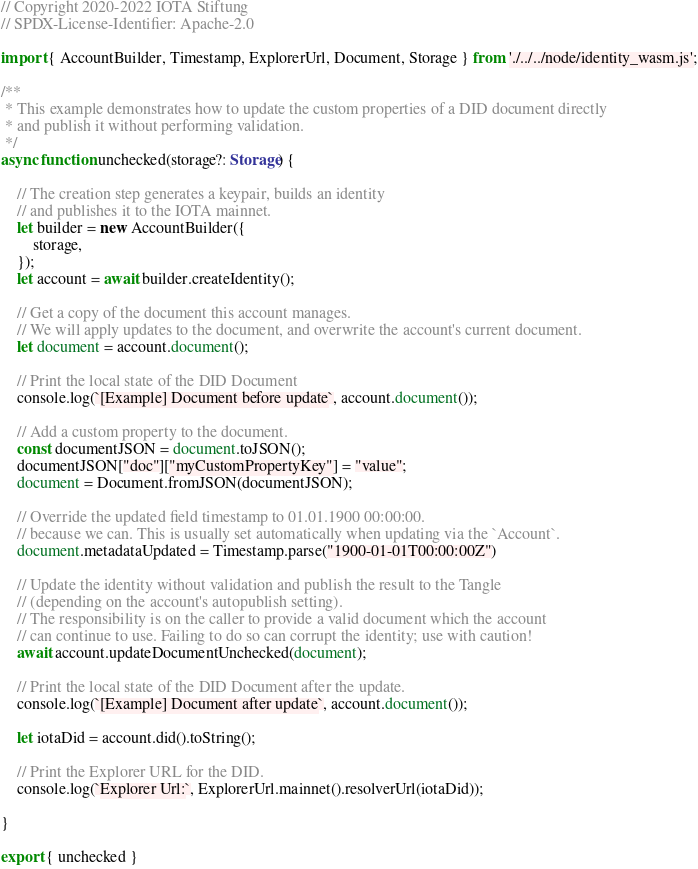Convert code to text. <code><loc_0><loc_0><loc_500><loc_500><_TypeScript_>// Copyright 2020-2022 IOTA Stiftung
// SPDX-License-Identifier: Apache-2.0

import { AccountBuilder, Timestamp, ExplorerUrl, Document, Storage } from './../../node/identity_wasm.js';

/**
 * This example demonstrates how to update the custom properties of a DID document directly 
 * and publish it without performing validation.
 */
async function unchecked(storage?: Storage) {

    // The creation step generates a keypair, builds an identity
    // and publishes it to the IOTA mainnet.
    let builder = new AccountBuilder({
        storage,
    });
    let account = await builder.createIdentity();

    // Get a copy of the document this account manages.
    // We will apply updates to the document, and overwrite the account's current document.
    let document = account.document();

    // Print the local state of the DID Document
    console.log(`[Example] Document before update`, account.document());

    // Add a custom property to the document.
    const documentJSON = document.toJSON();
    documentJSON["doc"]["myCustomPropertyKey"] = "value";
    document = Document.fromJSON(documentJSON);

    // Override the updated field timestamp to 01.01.1900 00:00:00.
    // because we can. This is usually set automatically when updating via the `Account`.
    document.metadataUpdated = Timestamp.parse("1900-01-01T00:00:00Z")

    // Update the identity without validation and publish the result to the Tangle
    // (depending on the account's autopublish setting).
    // The responsibility is on the caller to provide a valid document which the account
    // can continue to use. Failing to do so can corrupt the identity; use with caution!
    await account.updateDocumentUnchecked(document);

    // Print the local state of the DID Document after the update.
    console.log(`[Example] Document after update`, account.document());

    let iotaDid = account.did().toString();
    
    // Print the Explorer URL for the DID.
    console.log(`Explorer Url:`, ExplorerUrl.mainnet().resolverUrl(iotaDid));

}

export { unchecked }
</code> 